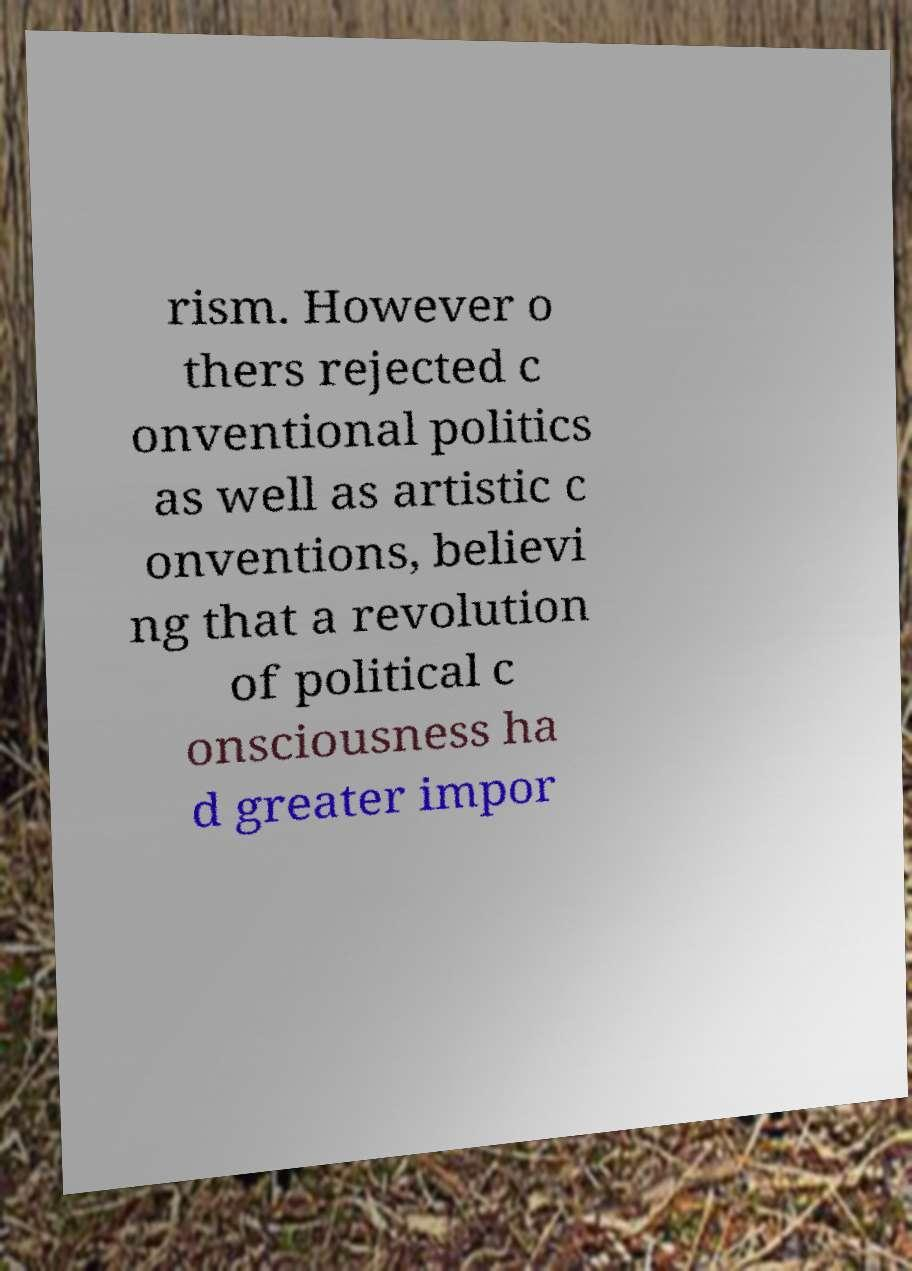Please identify and transcribe the text found in this image. rism. However o thers rejected c onventional politics as well as artistic c onventions, believi ng that a revolution of political c onsciousness ha d greater impor 